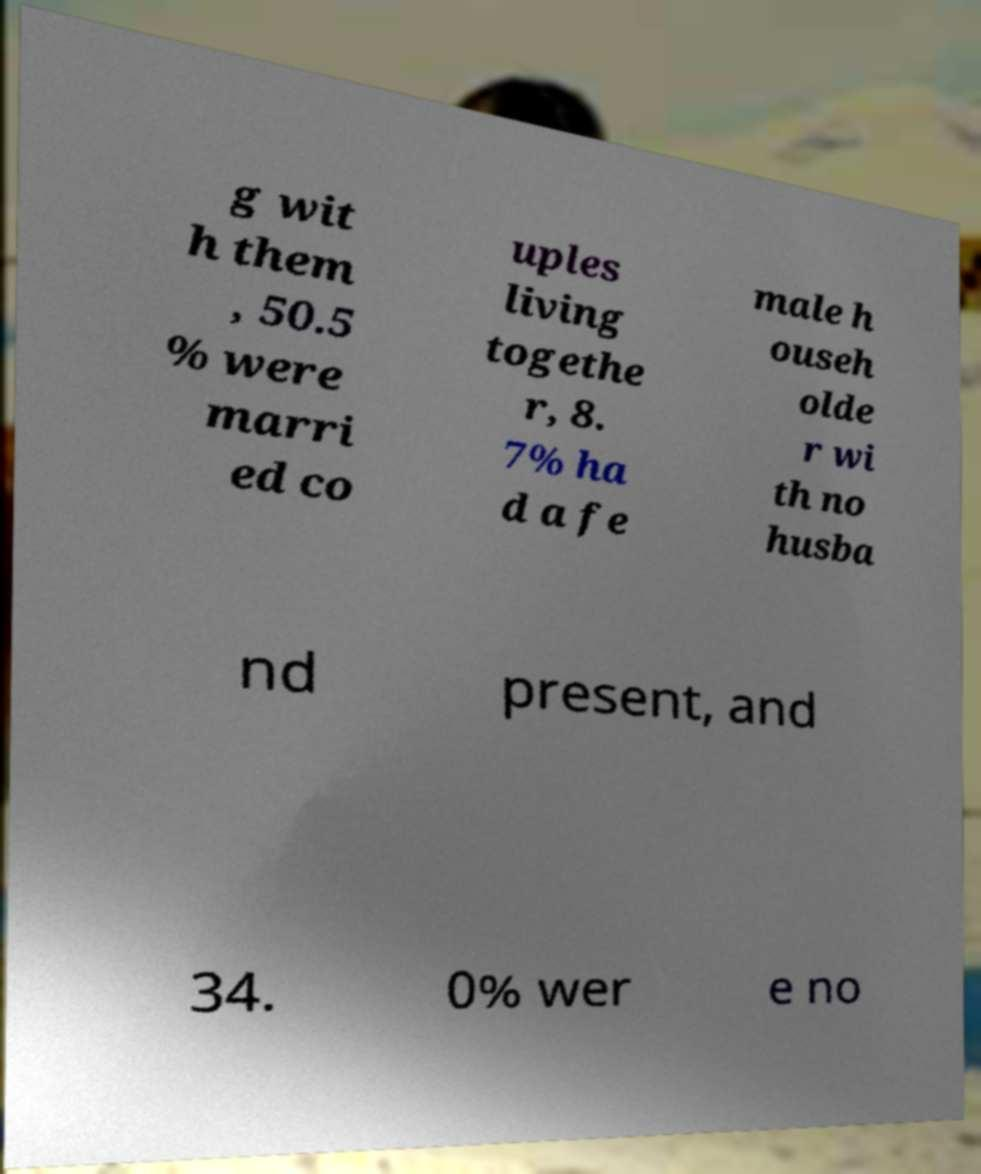Can you accurately transcribe the text from the provided image for me? g wit h them , 50.5 % were marri ed co uples living togethe r, 8. 7% ha d a fe male h ouseh olde r wi th no husba nd present, and 34. 0% wer e no 